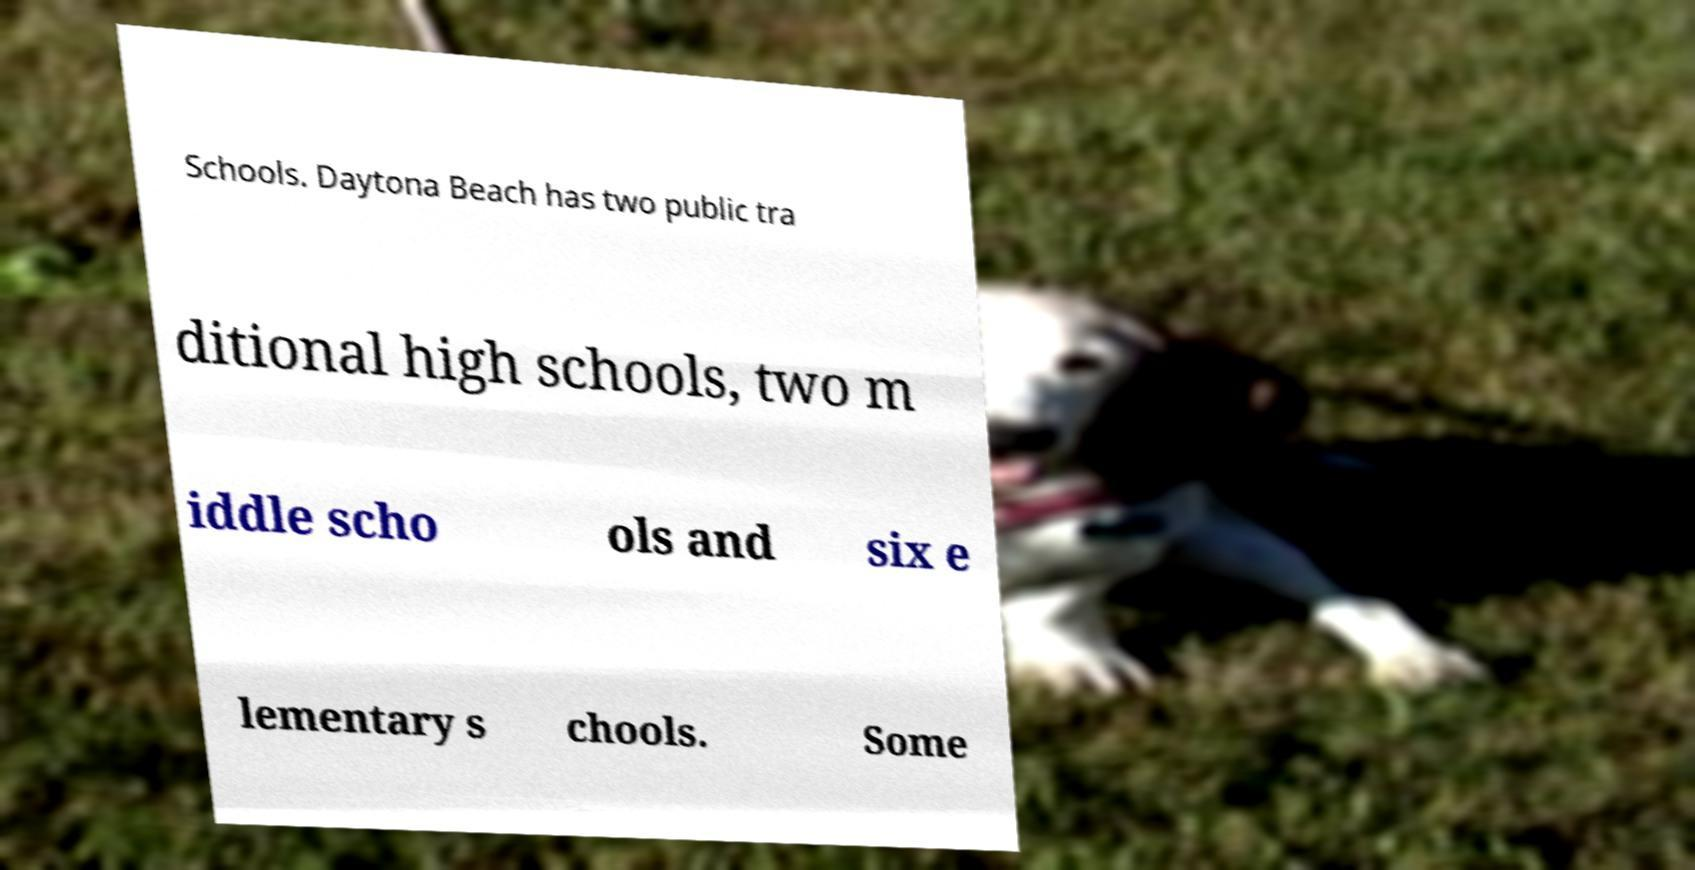For documentation purposes, I need the text within this image transcribed. Could you provide that? Schools. Daytona Beach has two public tra ditional high schools, two m iddle scho ols and six e lementary s chools. Some 